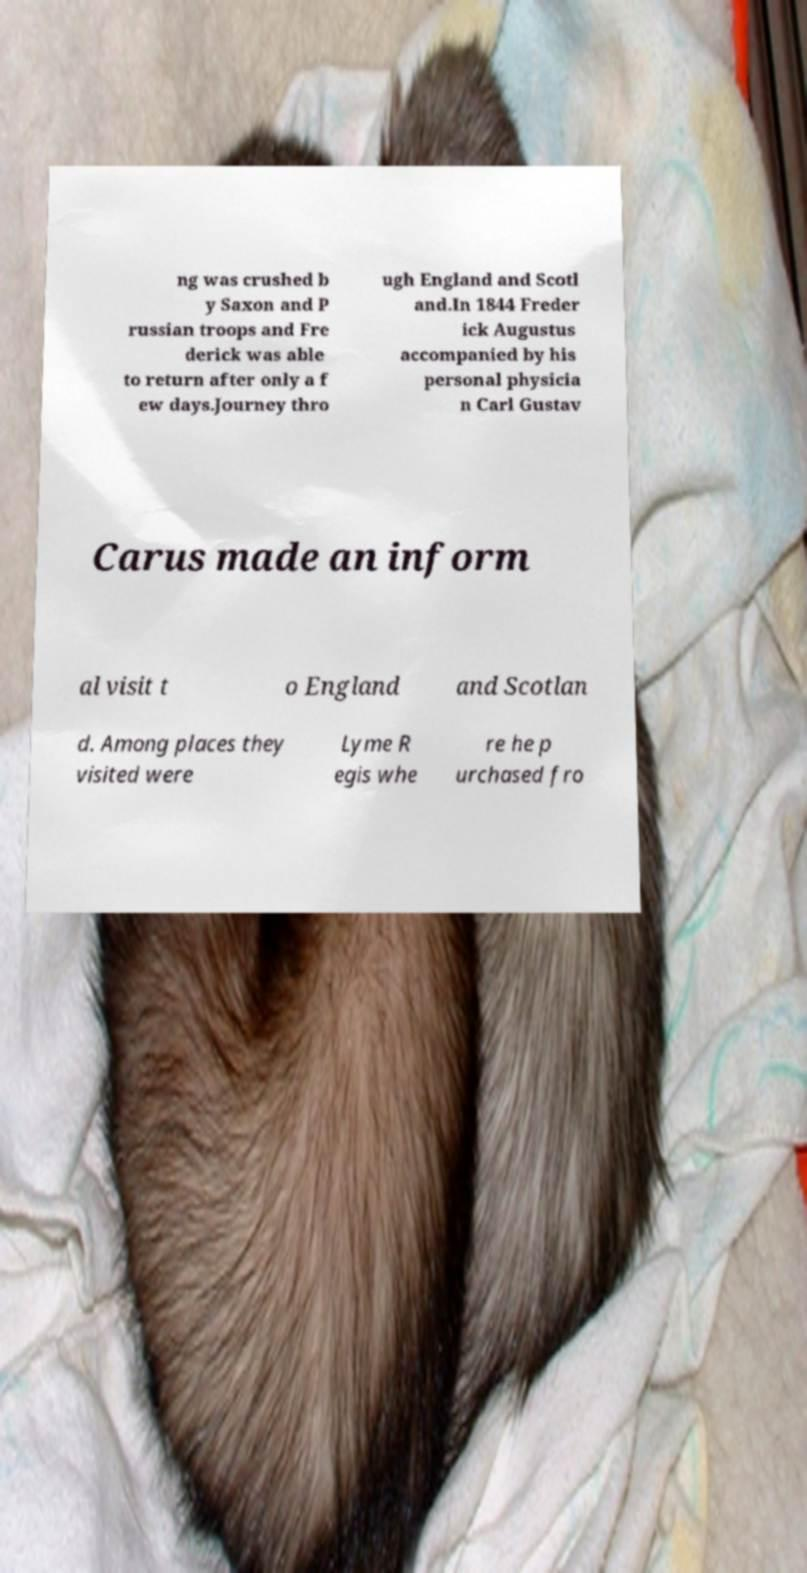For documentation purposes, I need the text within this image transcribed. Could you provide that? ng was crushed b y Saxon and P russian troops and Fre derick was able to return after only a f ew days.Journey thro ugh England and Scotl and.In 1844 Freder ick Augustus accompanied by his personal physicia n Carl Gustav Carus made an inform al visit t o England and Scotlan d. Among places they visited were Lyme R egis whe re he p urchased fro 